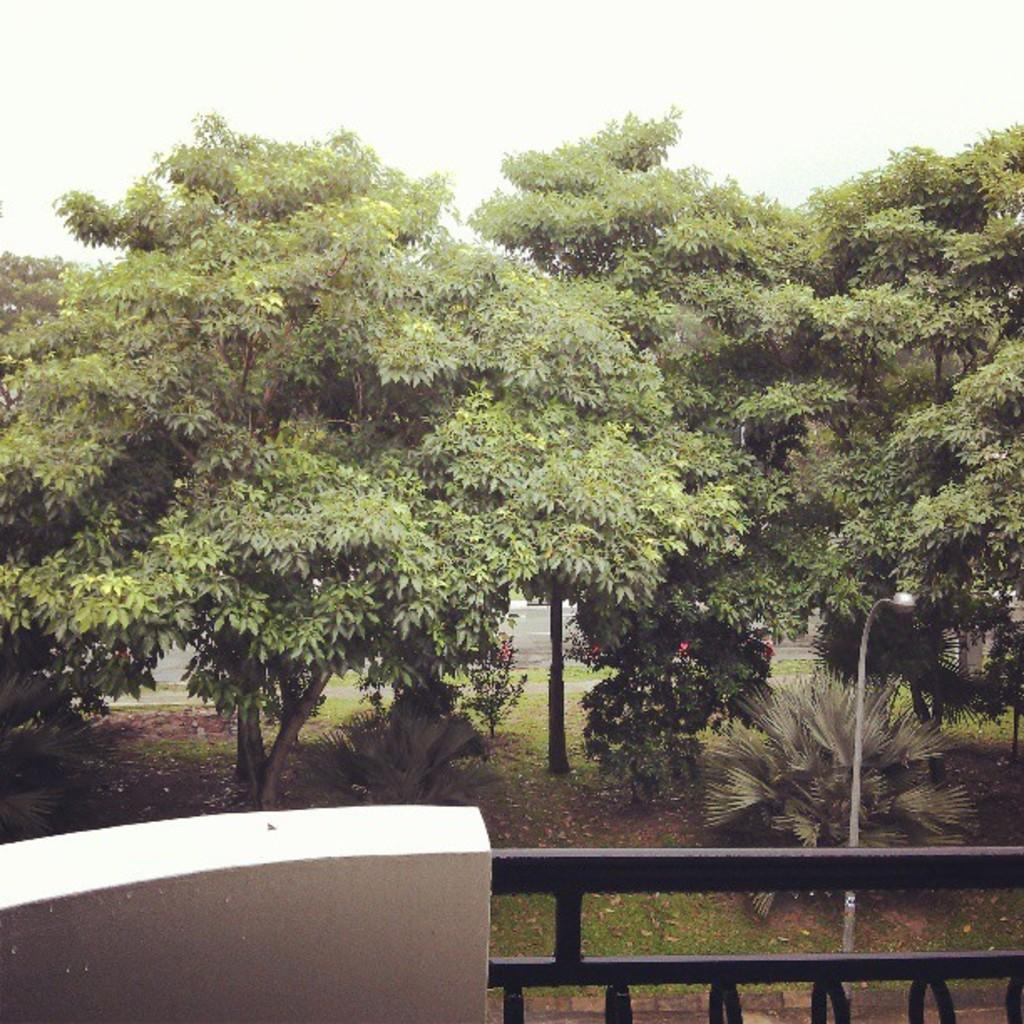What type of vegetation is present in the image? There are many trees in the image. What structure can be seen in the image besides the trees? There is a light pole in the image. What is located at the bottom of the image? There is a railing at the bottom of the image. What can be seen in the distance in the image? The sky is visible in the background of the image. What type of cloud can be seen at the top of the image? There is no cloud visible at the top of the image; only the sky is visible. What is the purpose of the wire in the image? There is no wire present in the image. 